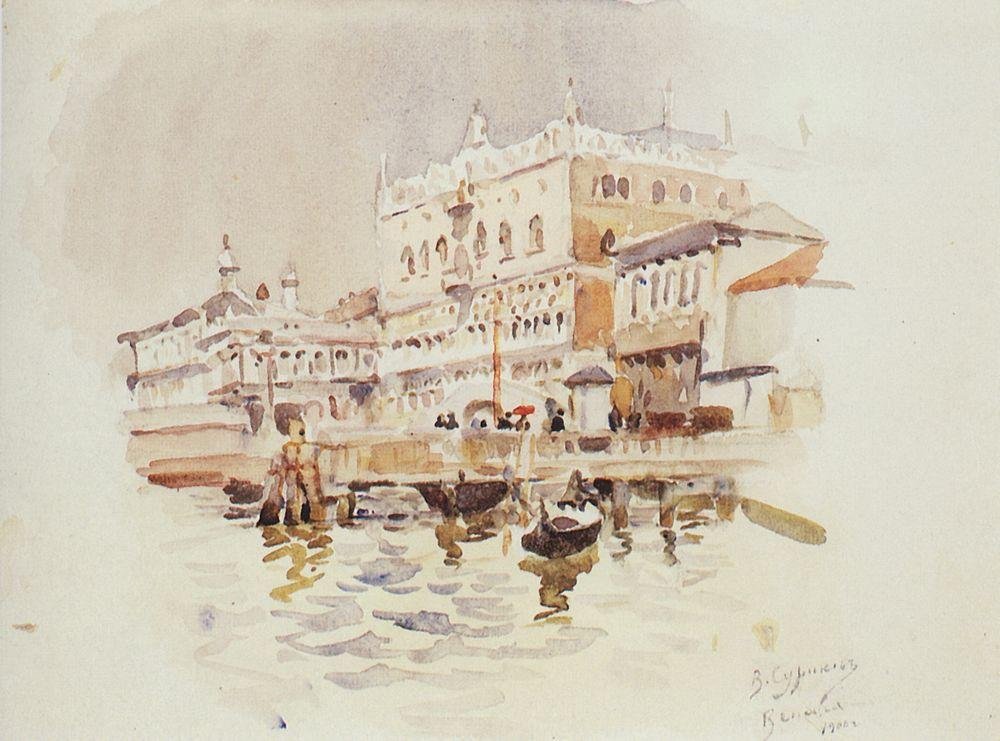Imagine a story behind the people on the boats in this scene. In one of the boats, a young couple enjoys a romantic gondola ride, captivated by the beauty of Venice. They are on their honeymoon, and this ride marks the beginning of their lifelong journey together. As they glide through the canal, they marvel at the grandeur of the palaces and dream of future visits to Venice. In another boat, a local Venetian merchant transports goods to the market. He's been navigating these waters for years and knows every corner of the canal. He exchanges greetings with other boatmen and offers stories of the city's history to tourists eager to learn more about Venice. 